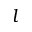Convert formula to latex. <formula><loc_0><loc_0><loc_500><loc_500>l</formula> 